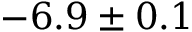<formula> <loc_0><loc_0><loc_500><loc_500>- 6 . 9 \pm 0 . 1</formula> 